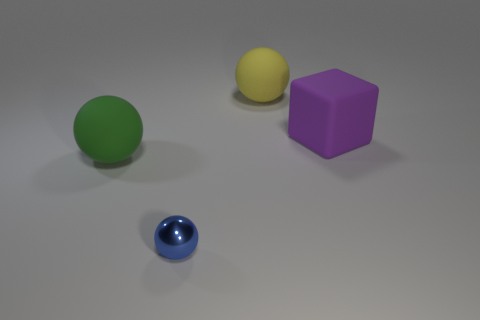Add 3 blue shiny blocks. How many objects exist? 7 Subtract all spheres. How many objects are left? 1 Subtract 0 cyan balls. How many objects are left? 4 Subtract all small blue shiny balls. Subtract all blue metallic spheres. How many objects are left? 2 Add 2 tiny blue balls. How many tiny blue balls are left? 3 Add 3 small blue balls. How many small blue balls exist? 4 